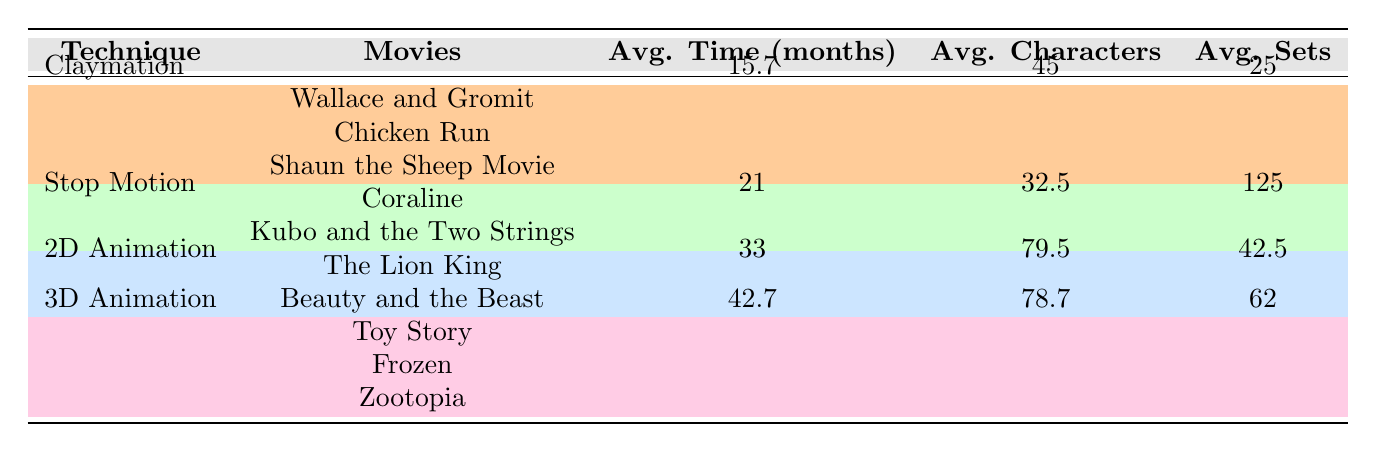What is the average production time for claymation movies? There are three claymation movies listed: Wallace and Gromit with 18 months, Chicken Run with 15 months, and Shaun the Sheep Movie with 14 months. To find the average, we add the production times: 18 + 15 + 14 = 47. Then we divide by the number of movies, which is 3: 47 / 3 = 15.7.
Answer: 15.7 months Which animation technique has the highest average production time? The table shows the average production time for each technique: Claymation (15.7 months), Stop Motion (21 months), 2D Animation (33 months), and 3D Animation (42.7 months). Comparing these, 3D Animation has the highest average production time at 42.7 months.
Answer: 3D Animation Does any animation technique take less than 20 months for production? Examining the average production times, we see that Claymation (15.7 months) and Stop Motion (21 months) are the two techniques. Since 15.7 months is less than 20 months and 21 months is not, the answer is yes, Claymation takes less than 20 months.
Answer: Yes What is the average number of characters in 3D Animation movies? The 3D Animation movies are Toy Story (76 characters), Frozen (65 characters), and Zootopia (95 characters). Adding these together gives us 76 + 65 + 95 = 236. There are three movies, so we divide the total by 3: 236 / 3 = 78.67. Thus, the average number of characters in 3D Animation is approximately 78.7.
Answer: 78.7 characters How many more average sets does Stop Motion have compared to Claymation? The average number of sets for Stop Motion is 125 and for Claymation is 25. To find the difference, we subtract 25 from 125: 125 - 25 = 100. Therefore, Stop Motion has 100 more average sets than Claymation.
Answer: 100 more sets 